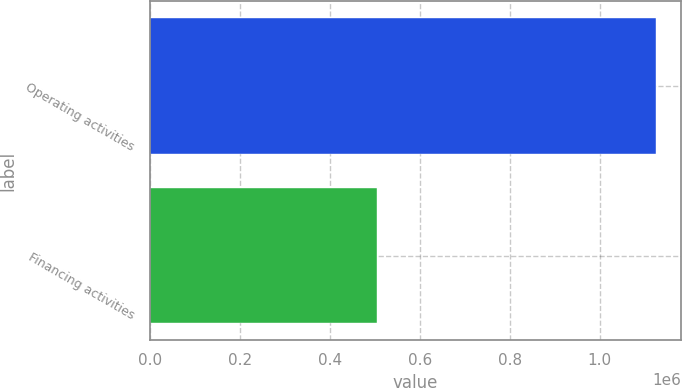<chart> <loc_0><loc_0><loc_500><loc_500><bar_chart><fcel>Operating activities<fcel>Financing activities<nl><fcel>1.12468e+06<fcel>504617<nl></chart> 